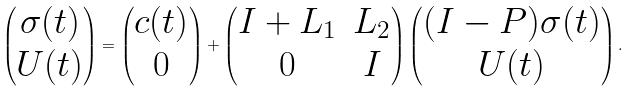Convert formula to latex. <formula><loc_0><loc_0><loc_500><loc_500>\begin{pmatrix} \sigma ( t ) \\ U ( t ) \end{pmatrix} = \begin{pmatrix} c ( t ) \\ 0 \end{pmatrix} + \begin{pmatrix} I + L _ { 1 } & L _ { 2 } \\ 0 & I \end{pmatrix} \begin{pmatrix} ( I - P ) \sigma ( t ) \\ U ( t ) \end{pmatrix} .</formula> 